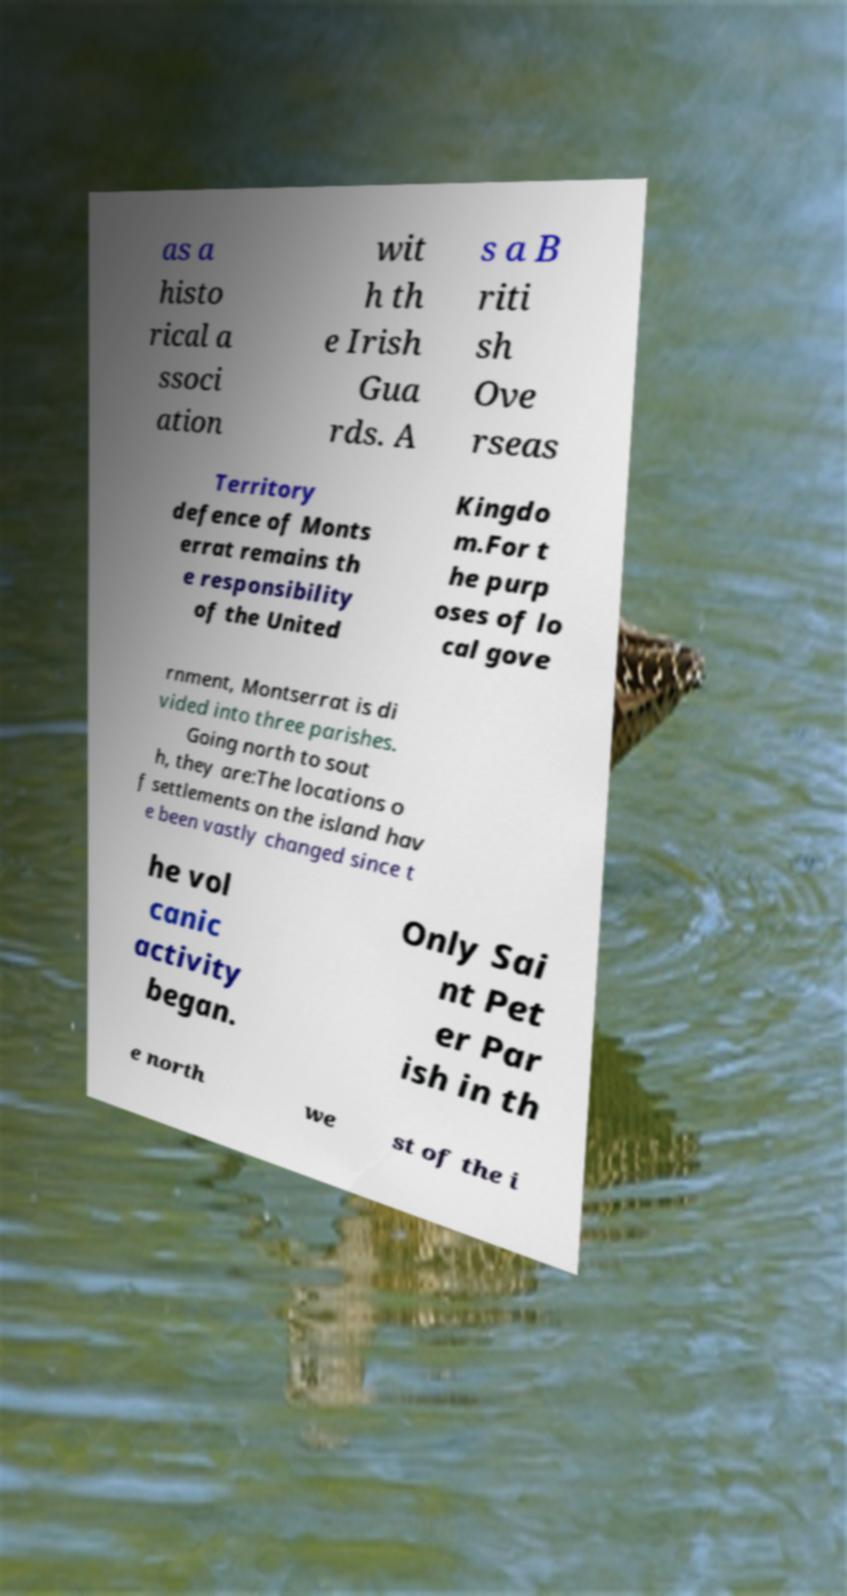Can you accurately transcribe the text from the provided image for me? as a histo rical a ssoci ation wit h th e Irish Gua rds. A s a B riti sh Ove rseas Territory defence of Monts errat remains th e responsibility of the United Kingdo m.For t he purp oses of lo cal gove rnment, Montserrat is di vided into three parishes. Going north to sout h, they are:The locations o f settlements on the island hav e been vastly changed since t he vol canic activity began. Only Sai nt Pet er Par ish in th e north we st of the i 